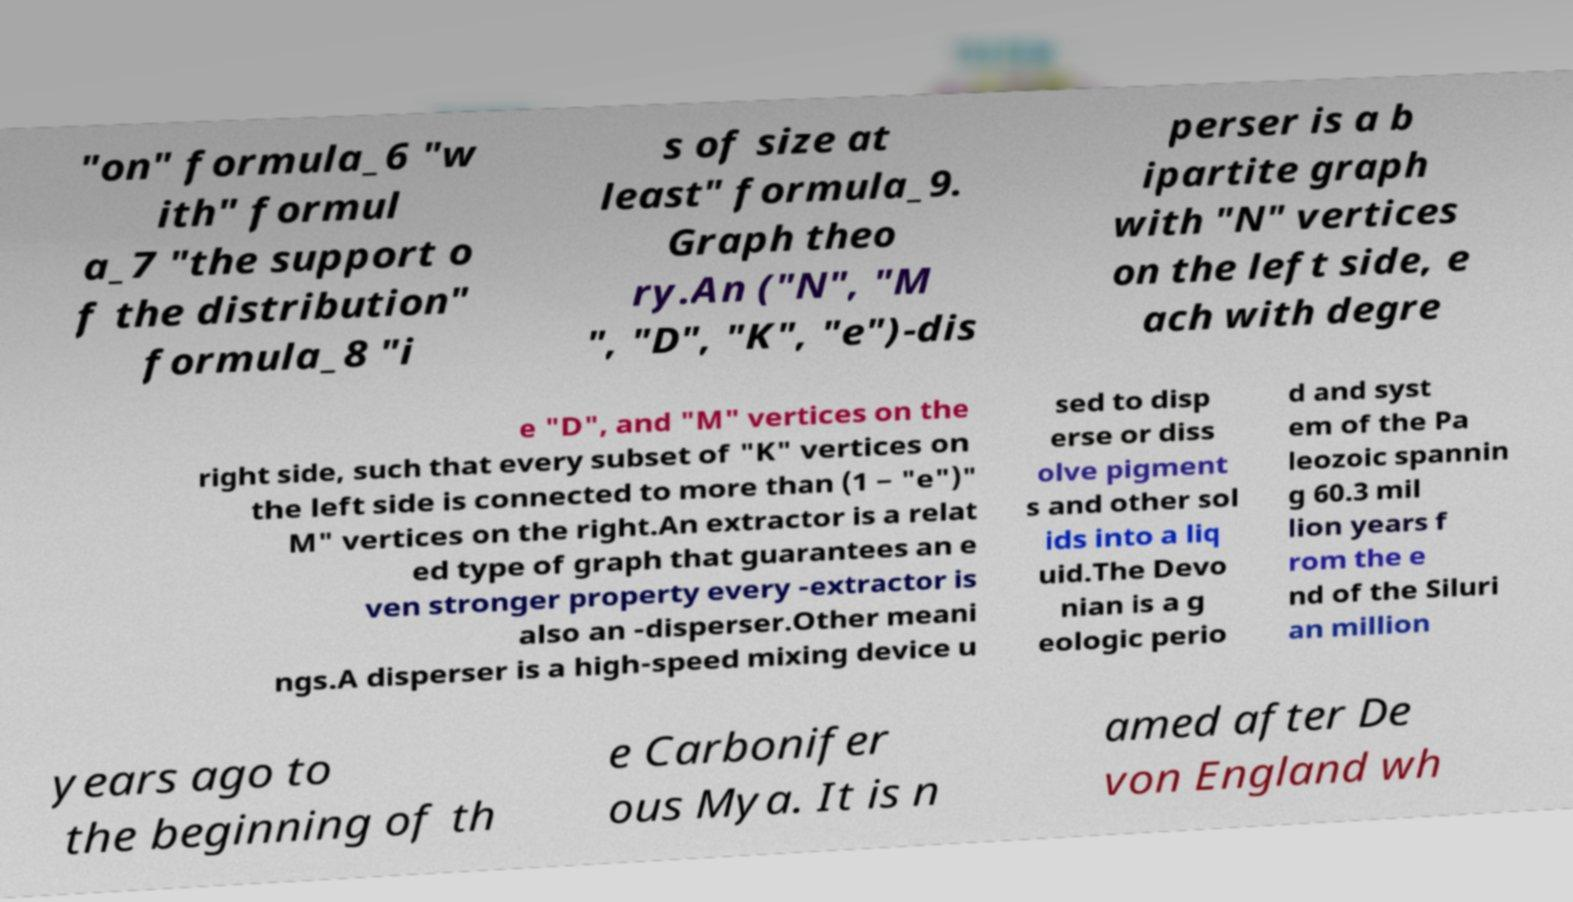Could you extract and type out the text from this image? "on" formula_6 "w ith" formul a_7 "the support o f the distribution" formula_8 "i s of size at least" formula_9. Graph theo ry.An ("N", "M ", "D", "K", "e")-dis perser is a b ipartite graph with "N" vertices on the left side, e ach with degre e "D", and "M" vertices on the right side, such that every subset of "K" vertices on the left side is connected to more than (1 − "e")" M" vertices on the right.An extractor is a relat ed type of graph that guarantees an e ven stronger property every -extractor is also an -disperser.Other meani ngs.A disperser is a high-speed mixing device u sed to disp erse or diss olve pigment s and other sol ids into a liq uid.The Devo nian is a g eologic perio d and syst em of the Pa leozoic spannin g 60.3 mil lion years f rom the e nd of the Siluri an million years ago to the beginning of th e Carbonifer ous Mya. It is n amed after De von England wh 